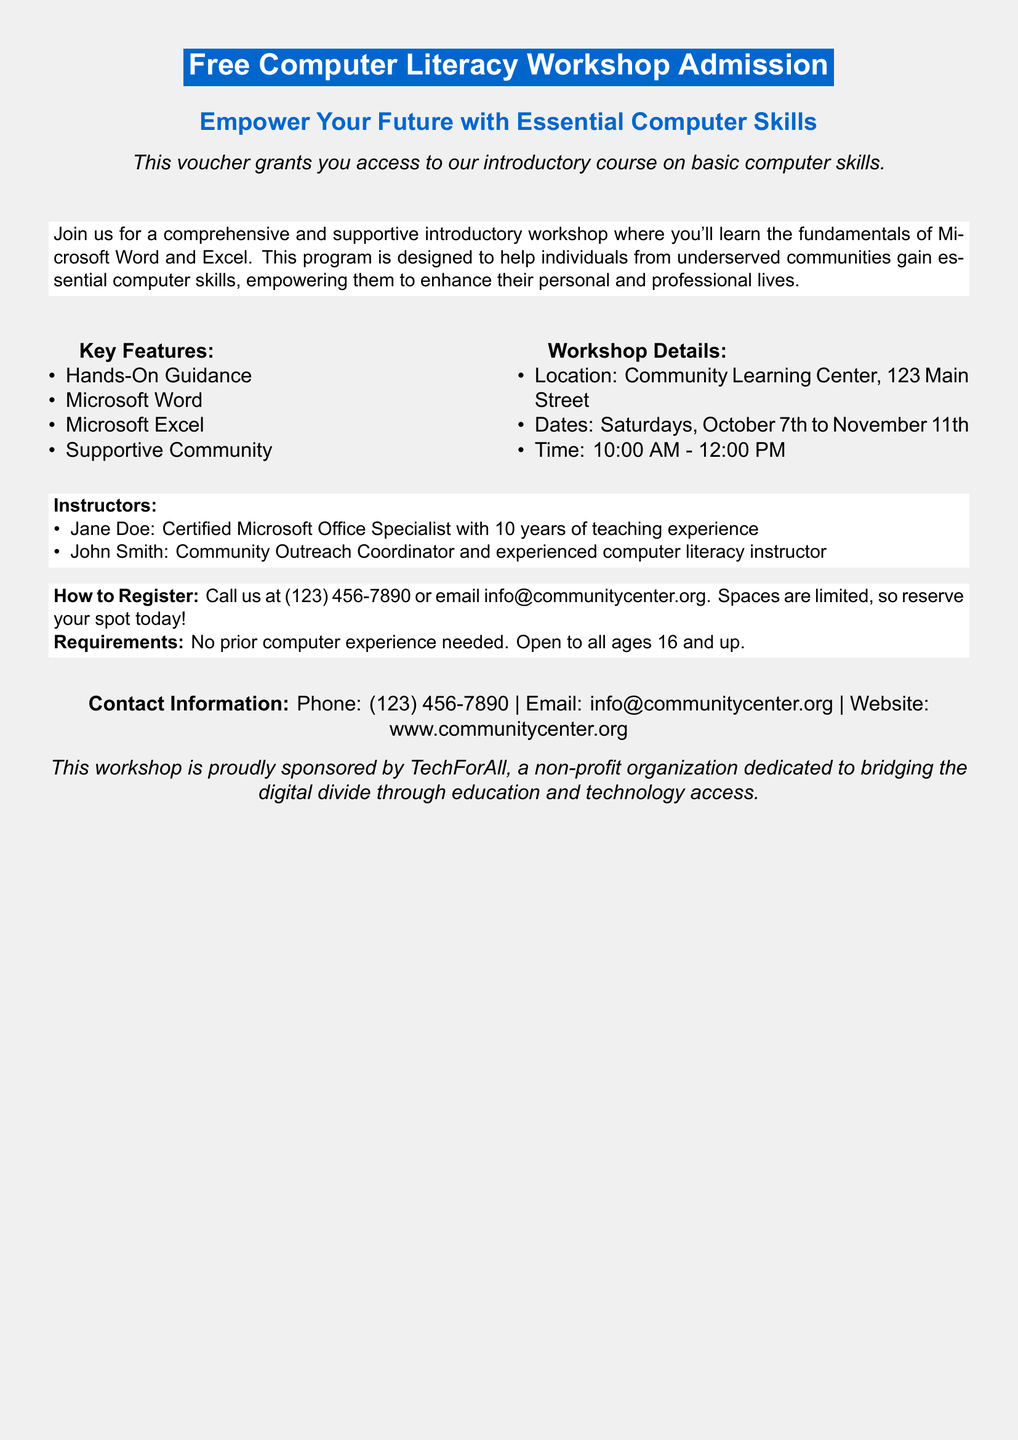What is the title of the workshop? The title of the workshop is clearly stated at the top of the document.
Answer: Free Computer Literacy Workshop Admission Where will the workshop be held? The document specifically mentions the location for the workshop.
Answer: Community Learning Center, 123 Main Street What days will the workshop take place? The document lists the dates when the workshop sessions are scheduled.
Answer: Saturdays, October 7th to November 11th What time does the workshop start? The document includes the starting time for the workshop in the timing details.
Answer: 10:00 AM Who is one of the instructors? The document provides information about the instructors of the workshop.
Answer: Jane Doe Is prior computer experience required to attend? The document contains information regarding any experience requirements for attendance.
Answer: No What is the contact phone number? The document includes a phone number for inquiries and registration.
Answer: (123) 456-7890 What is the age requirement to participate? The document states the minimum age requirement for the workshop participants.
Answer: 16 and up How can you register for the workshop? The document outlines the method of registration clearly.
Answer: Call us or email info@communitycenter.org 